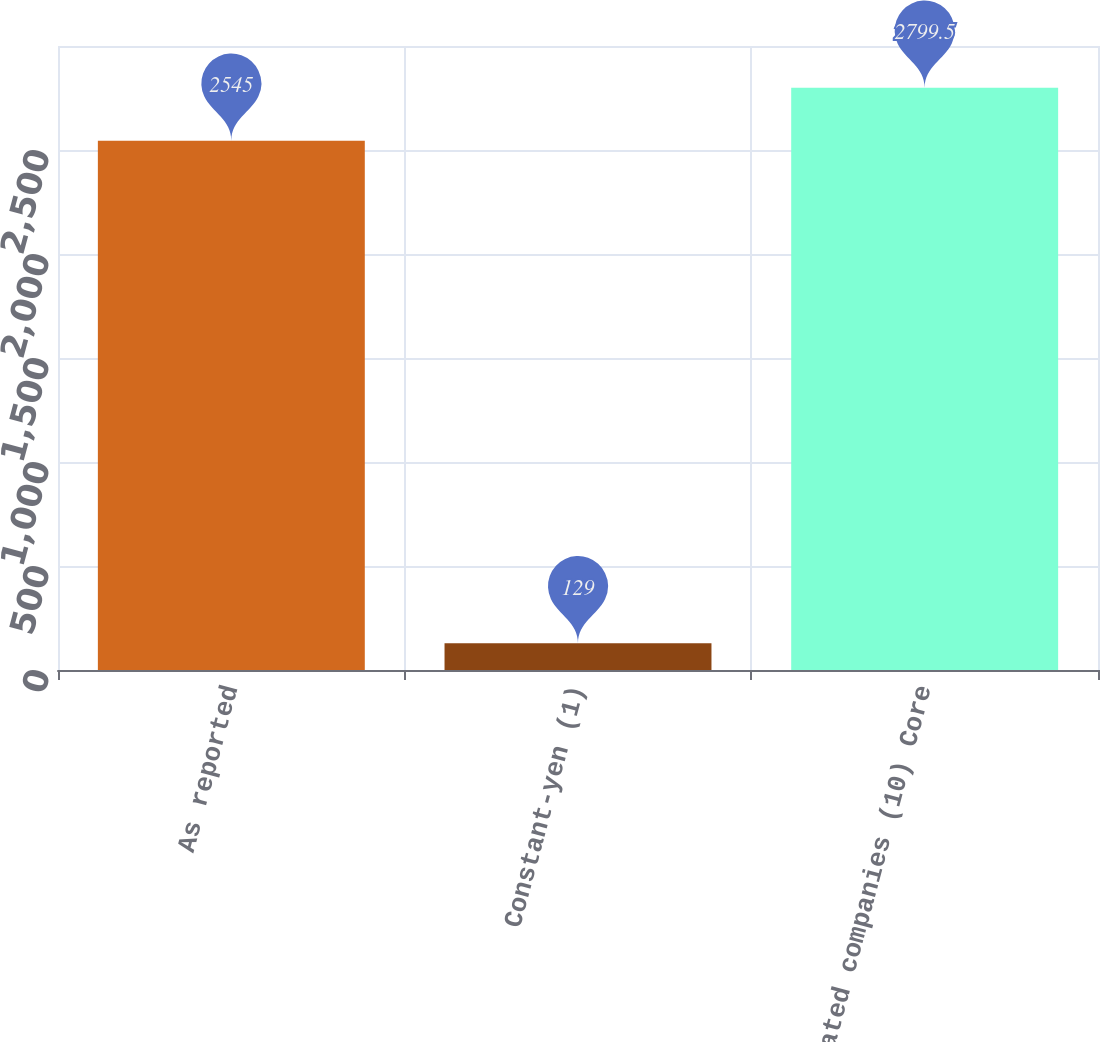Convert chart. <chart><loc_0><loc_0><loc_500><loc_500><bar_chart><fcel>As reported<fcel>Constant-yen (1)<fcel>affiliated companies (10) Core<nl><fcel>2545<fcel>129<fcel>2799.5<nl></chart> 